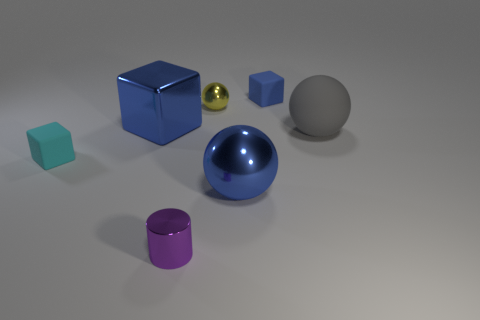Subtract all big metal blocks. How many blocks are left? 2 Subtract all blue cylinders. How many blue cubes are left? 2 Add 1 tiny purple cylinders. How many objects exist? 8 Subtract all blue cubes. How many cubes are left? 1 Subtract all blocks. How many objects are left? 4 Subtract 1 cubes. How many cubes are left? 2 Subtract all purple spheres. Subtract all red cubes. How many spheres are left? 3 Add 6 blue metal things. How many blue metal things are left? 8 Add 7 yellow objects. How many yellow objects exist? 8 Subtract 0 yellow cubes. How many objects are left? 7 